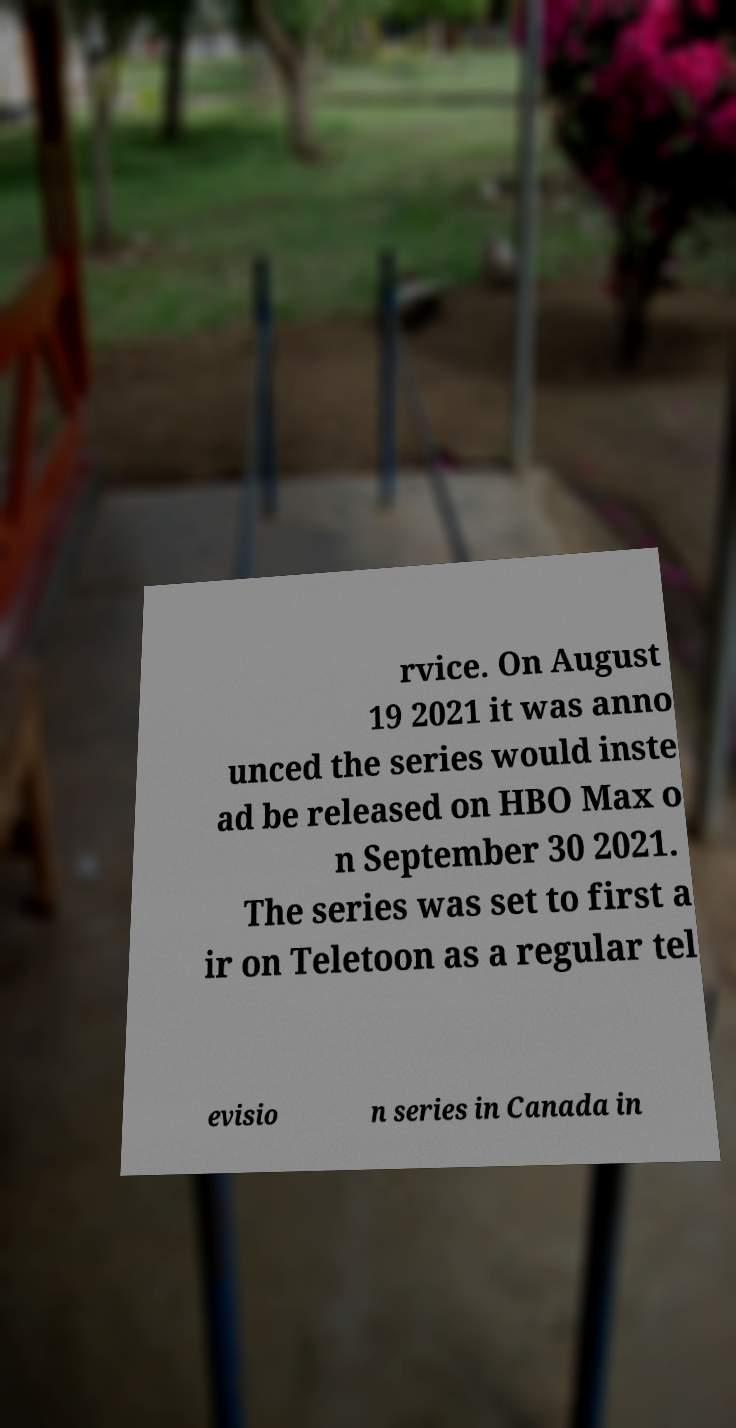Could you extract and type out the text from this image? rvice. On August 19 2021 it was anno unced the series would inste ad be released on HBO Max o n September 30 2021. The series was set to first a ir on Teletoon as a regular tel evisio n series in Canada in 